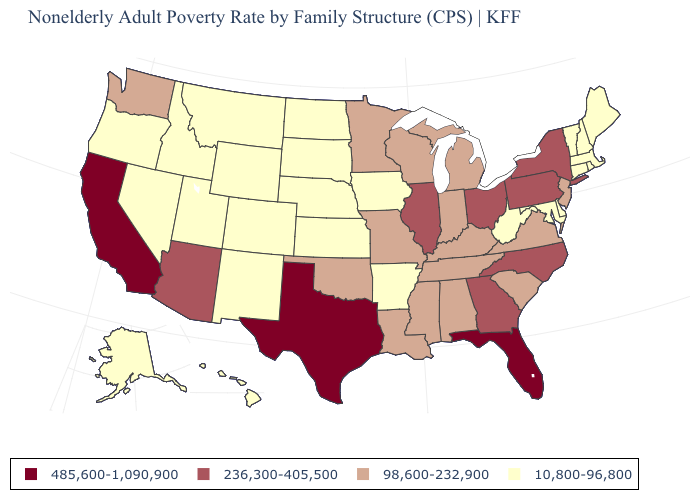What is the highest value in the USA?
Answer briefly. 485,600-1,090,900. How many symbols are there in the legend?
Be succinct. 4. Name the states that have a value in the range 98,600-232,900?
Keep it brief. Alabama, Indiana, Kentucky, Louisiana, Michigan, Minnesota, Mississippi, Missouri, New Jersey, Oklahoma, South Carolina, Tennessee, Virginia, Washington, Wisconsin. What is the value of South Carolina?
Keep it brief. 98,600-232,900. What is the lowest value in states that border Florida?
Concise answer only. 98,600-232,900. What is the value of Kansas?
Keep it brief. 10,800-96,800. Among the states that border Rhode Island , which have the lowest value?
Answer briefly. Connecticut, Massachusetts. What is the value of Iowa?
Be succinct. 10,800-96,800. Which states have the lowest value in the West?
Write a very short answer. Alaska, Colorado, Hawaii, Idaho, Montana, Nevada, New Mexico, Oregon, Utah, Wyoming. Does Alabama have a lower value than Florida?
Write a very short answer. Yes. Among the states that border Wisconsin , does Michigan have the highest value?
Give a very brief answer. No. Name the states that have a value in the range 236,300-405,500?
Concise answer only. Arizona, Georgia, Illinois, New York, North Carolina, Ohio, Pennsylvania. What is the highest value in states that border Delaware?
Write a very short answer. 236,300-405,500. Does the first symbol in the legend represent the smallest category?
Give a very brief answer. No. Does the first symbol in the legend represent the smallest category?
Concise answer only. No. 